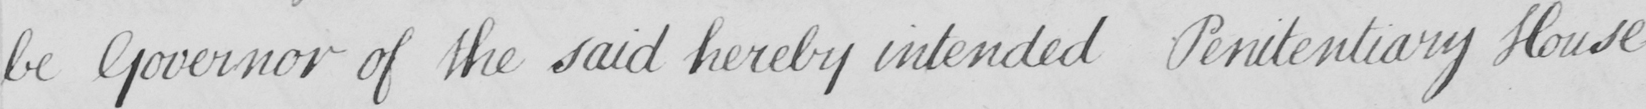What text is written in this handwritten line? be Governor of the said hereby intended Penitentiary House 